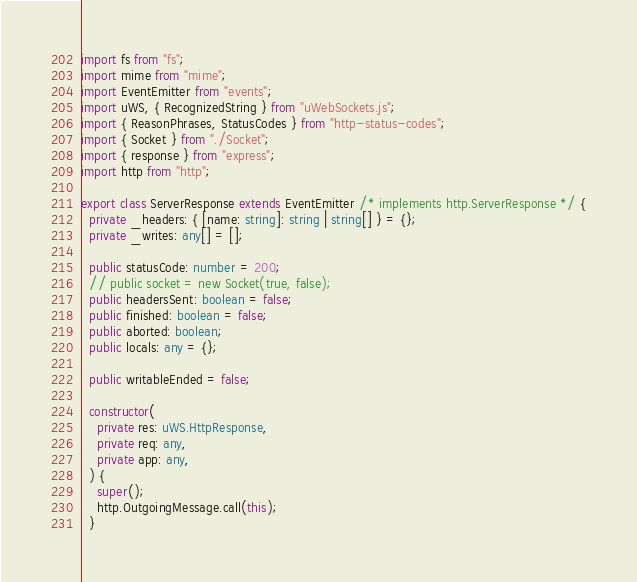<code> <loc_0><loc_0><loc_500><loc_500><_TypeScript_>import fs from "fs";
import mime from "mime";
import EventEmitter from "events";
import uWS, { RecognizedString } from "uWebSockets.js";
import { ReasonPhrases, StatusCodes } from "http-status-codes";
import { Socket } from "./Socket";
import { response } from "express";
import http from "http";

export class ServerResponse extends EventEmitter /* implements http.ServerResponse */ {
  private _headers: { [name: string]: string | string[] } = {};
  private _writes: any[] = [];

  public statusCode: number = 200;
  // public socket = new Socket(true, false);
  public headersSent: boolean = false;
  public finished: boolean = false;
  public aborted: boolean;
  public locals: any = {};

  public writableEnded = false;

  constructor(
    private res: uWS.HttpResponse,
    private req: any,
    private app: any,
  ) {
    super();
    http.OutgoingMessage.call(this);
  }
</code> 